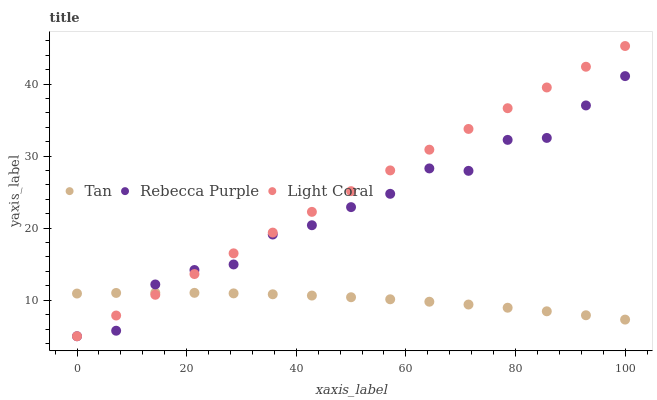Does Tan have the minimum area under the curve?
Answer yes or no. Yes. Does Light Coral have the maximum area under the curve?
Answer yes or no. Yes. Does Rebecca Purple have the minimum area under the curve?
Answer yes or no. No. Does Rebecca Purple have the maximum area under the curve?
Answer yes or no. No. Is Light Coral the smoothest?
Answer yes or no. Yes. Is Rebecca Purple the roughest?
Answer yes or no. Yes. Is Tan the smoothest?
Answer yes or no. No. Is Tan the roughest?
Answer yes or no. No. Does Light Coral have the lowest value?
Answer yes or no. Yes. Does Tan have the lowest value?
Answer yes or no. No. Does Light Coral have the highest value?
Answer yes or no. Yes. Does Rebecca Purple have the highest value?
Answer yes or no. No. Does Rebecca Purple intersect Light Coral?
Answer yes or no. Yes. Is Rebecca Purple less than Light Coral?
Answer yes or no. No. Is Rebecca Purple greater than Light Coral?
Answer yes or no. No. 